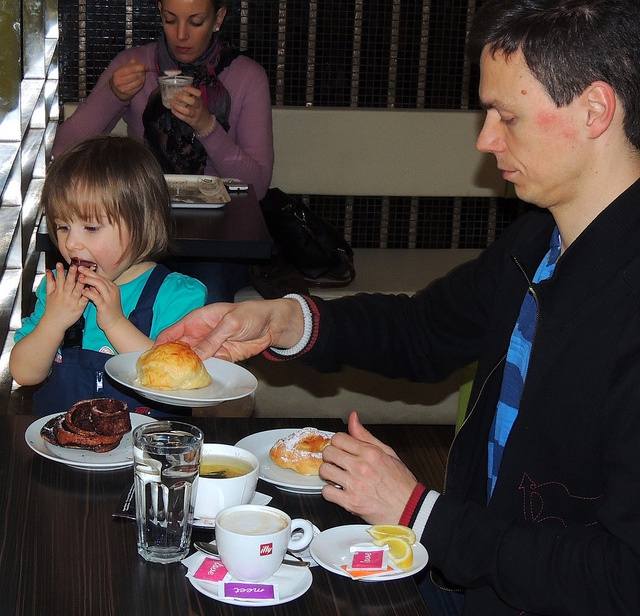Describe the objects in this image and their specific colors. I can see people in darkgreen, black, tan, and gray tones, dining table in darkgreen, black, gray, and darkgray tones, chair in darkgreen, gray, and black tones, people in darkgreen, black, tan, gray, and teal tones, and people in darkgreen, black, maroon, purple, and brown tones in this image. 